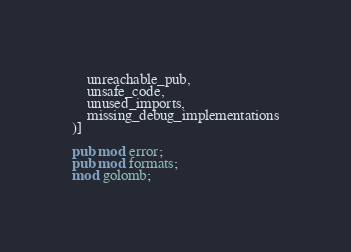Convert code to text. <code><loc_0><loc_0><loc_500><loc_500><_Rust_>    unreachable_pub,
    unsafe_code,
    unused_imports,
    missing_debug_implementations
)]

pub mod error;
pub mod formats;
mod golomb;
</code> 